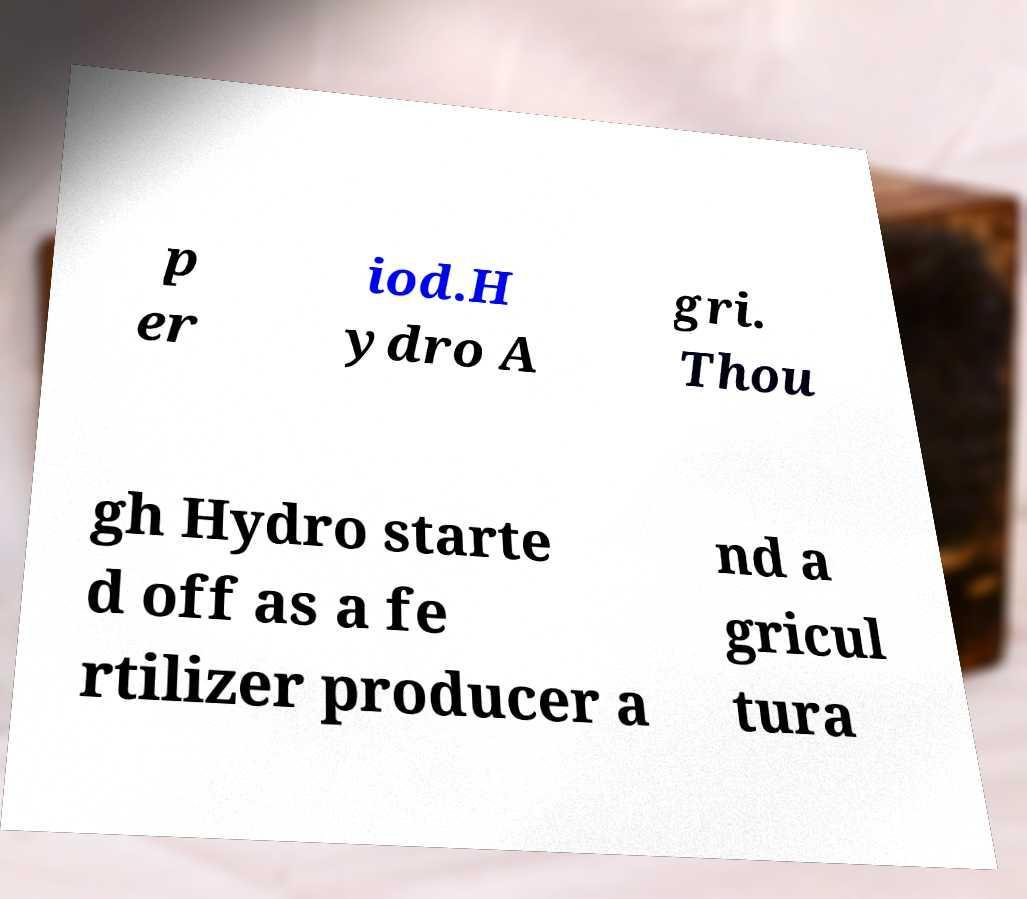What messages or text are displayed in this image? I need them in a readable, typed format. p er iod.H ydro A gri. Thou gh Hydro starte d off as a fe rtilizer producer a nd a gricul tura 